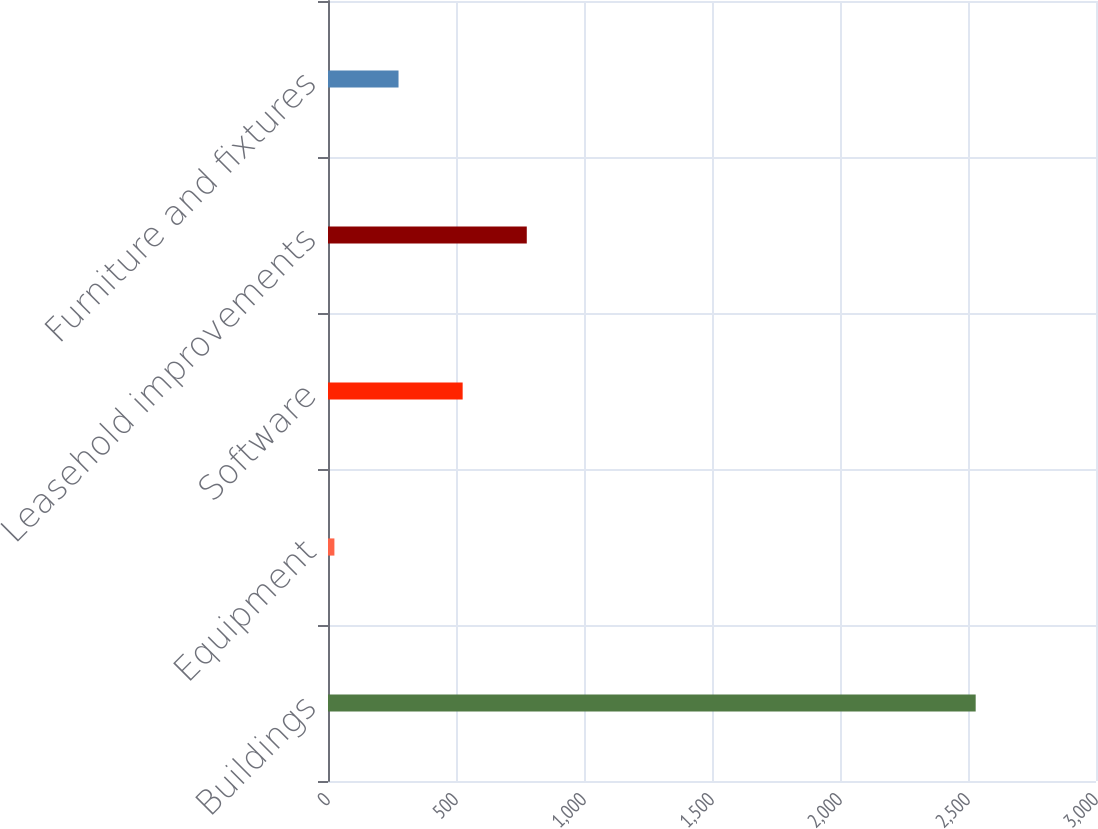Convert chart to OTSL. <chart><loc_0><loc_0><loc_500><loc_500><bar_chart><fcel>Buildings<fcel>Equipment<fcel>Software<fcel>Leasehold improvements<fcel>Furniture and fixtures<nl><fcel>2530<fcel>25<fcel>526<fcel>776.5<fcel>275.5<nl></chart> 